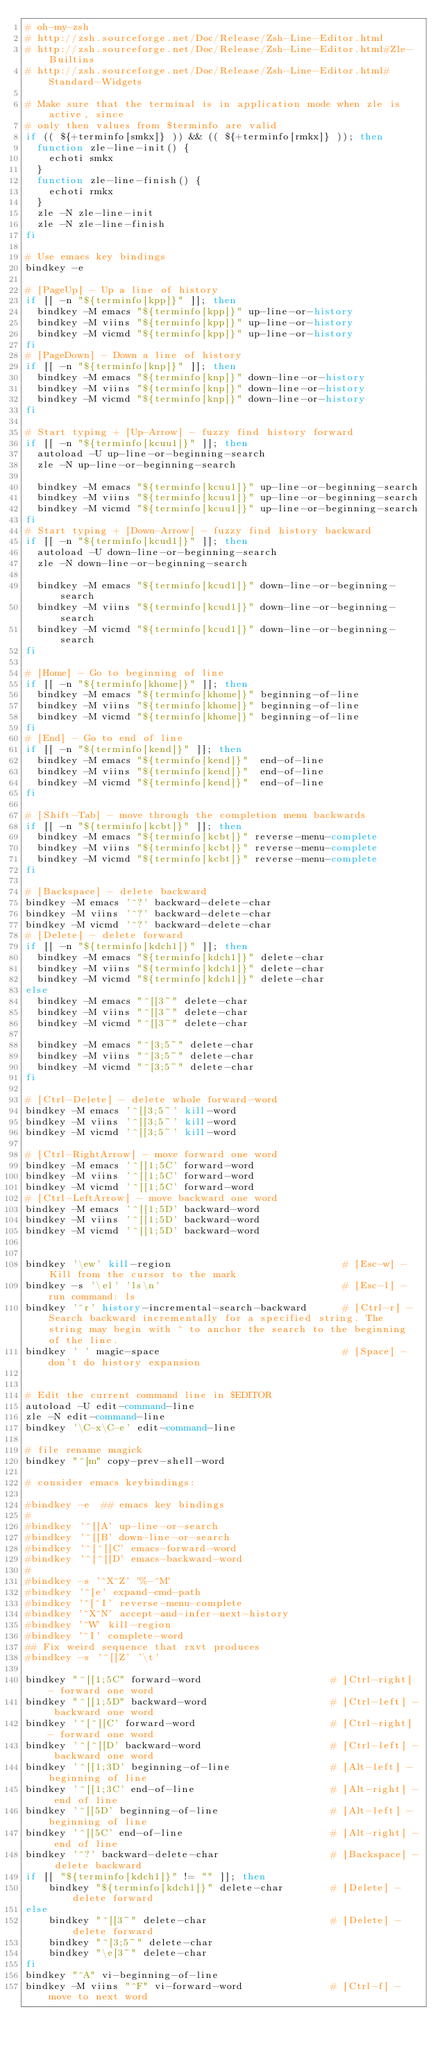Convert code to text. <code><loc_0><loc_0><loc_500><loc_500><_Bash_># oh-my-zsh
# http://zsh.sourceforge.net/Doc/Release/Zsh-Line-Editor.html
# http://zsh.sourceforge.net/Doc/Release/Zsh-Line-Editor.html#Zle-Builtins
# http://zsh.sourceforge.net/Doc/Release/Zsh-Line-Editor.html#Standard-Widgets

# Make sure that the terminal is in application mode when zle is active, since
# only then values from $terminfo are valid
if (( ${+terminfo[smkx]} )) && (( ${+terminfo[rmkx]} )); then
  function zle-line-init() {
    echoti smkx
  }
  function zle-line-finish() {
    echoti rmkx
  }
  zle -N zle-line-init
  zle -N zle-line-finish
fi

# Use emacs key bindings
bindkey -e

# [PageUp] - Up a line of history
if [[ -n "${terminfo[kpp]}" ]]; then
  bindkey -M emacs "${terminfo[kpp]}" up-line-or-history
  bindkey -M viins "${terminfo[kpp]}" up-line-or-history
  bindkey -M vicmd "${terminfo[kpp]}" up-line-or-history
fi
# [PageDown] - Down a line of history
if [[ -n "${terminfo[knp]}" ]]; then
  bindkey -M emacs "${terminfo[knp]}" down-line-or-history
  bindkey -M viins "${terminfo[knp]}" down-line-or-history
  bindkey -M vicmd "${terminfo[knp]}" down-line-or-history
fi

# Start typing + [Up-Arrow] - fuzzy find history forward
if [[ -n "${terminfo[kcuu1]}" ]]; then
  autoload -U up-line-or-beginning-search
  zle -N up-line-or-beginning-search

  bindkey -M emacs "${terminfo[kcuu1]}" up-line-or-beginning-search
  bindkey -M viins "${terminfo[kcuu1]}" up-line-or-beginning-search
  bindkey -M vicmd "${terminfo[kcuu1]}" up-line-or-beginning-search
fi
# Start typing + [Down-Arrow] - fuzzy find history backward
if [[ -n "${terminfo[kcud1]}" ]]; then
  autoload -U down-line-or-beginning-search
  zle -N down-line-or-beginning-search

  bindkey -M emacs "${terminfo[kcud1]}" down-line-or-beginning-search
  bindkey -M viins "${terminfo[kcud1]}" down-line-or-beginning-search
  bindkey -M vicmd "${terminfo[kcud1]}" down-line-or-beginning-search
fi

# [Home] - Go to beginning of line
if [[ -n "${terminfo[khome]}" ]]; then
  bindkey -M emacs "${terminfo[khome]}" beginning-of-line
  bindkey -M viins "${terminfo[khome]}" beginning-of-line
  bindkey -M vicmd "${terminfo[khome]}" beginning-of-line
fi
# [End] - Go to end of line
if [[ -n "${terminfo[kend]}" ]]; then
  bindkey -M emacs "${terminfo[kend]}"  end-of-line
  bindkey -M viins "${terminfo[kend]}"  end-of-line
  bindkey -M vicmd "${terminfo[kend]}"  end-of-line
fi

# [Shift-Tab] - move through the completion menu backwards
if [[ -n "${terminfo[kcbt]}" ]]; then
  bindkey -M emacs "${terminfo[kcbt]}" reverse-menu-complete
  bindkey -M viins "${terminfo[kcbt]}" reverse-menu-complete
  bindkey -M vicmd "${terminfo[kcbt]}" reverse-menu-complete
fi

# [Backspace] - delete backward
bindkey -M emacs '^?' backward-delete-char
bindkey -M viins '^?' backward-delete-char
bindkey -M vicmd '^?' backward-delete-char
# [Delete] - delete forward
if [[ -n "${terminfo[kdch1]}" ]]; then
  bindkey -M emacs "${terminfo[kdch1]}" delete-char
  bindkey -M viins "${terminfo[kdch1]}" delete-char
  bindkey -M vicmd "${terminfo[kdch1]}" delete-char
else
  bindkey -M emacs "^[[3~" delete-char
  bindkey -M viins "^[[3~" delete-char
  bindkey -M vicmd "^[[3~" delete-char

  bindkey -M emacs "^[3;5~" delete-char
  bindkey -M viins "^[3;5~" delete-char
  bindkey -M vicmd "^[3;5~" delete-char
fi

# [Ctrl-Delete] - delete whole forward-word
bindkey -M emacs '^[[3;5~' kill-word
bindkey -M viins '^[[3;5~' kill-word
bindkey -M vicmd '^[[3;5~' kill-word

# [Ctrl-RightArrow] - move forward one word
bindkey -M emacs '^[[1;5C' forward-word
bindkey -M viins '^[[1;5C' forward-word
bindkey -M vicmd '^[[1;5C' forward-word
# [Ctrl-LeftArrow] - move backward one word
bindkey -M emacs '^[[1;5D' backward-word
bindkey -M viins '^[[1;5D' backward-word
bindkey -M vicmd '^[[1;5D' backward-word


bindkey '\ew' kill-region                             # [Esc-w] - Kill from the cursor to the mark
bindkey -s '\el' 'ls\n'                               # [Esc-l] - run command: ls
bindkey '^r' history-incremental-search-backward      # [Ctrl-r] - Search backward incrementally for a specified string. The string may begin with ^ to anchor the search to the beginning of the line.
bindkey ' ' magic-space                               # [Space] - don't do history expansion


# Edit the current command line in $EDITOR
autoload -U edit-command-line
zle -N edit-command-line
bindkey '\C-x\C-e' edit-command-line

# file rename magick
bindkey "^[m" copy-prev-shell-word

# consider emacs keybindings:

#bindkey -e  ## emacs key bindings
#
#bindkey '^[[A' up-line-or-search
#bindkey '^[[B' down-line-or-search
#bindkey '^[^[[C' emacs-forward-word
#bindkey '^[^[[D' emacs-backward-word
#
#bindkey -s '^X^Z' '%-^M'
#bindkey '^[e' expand-cmd-path
#bindkey '^[^I' reverse-menu-complete
#bindkey '^X^N' accept-and-infer-next-history
#bindkey '^W' kill-region
#bindkey '^I' complete-word
## Fix weird sequence that rxvt produces
#bindkey -s '^[[Z' '\t'

bindkey "^[[1;5C" forward-word                      # [Ctrl-right] - forward one word
bindkey "^[[1;5D" backward-word                     # [Ctrl-left] - backward one word
bindkey '^[^[[C' forward-word                       # [Ctrl-right] - forward one word
bindkey '^[^[[D' backward-word                      # [Ctrl-left] - backward one word
bindkey '^[[1;3D' beginning-of-line                 # [Alt-left] - beginning of line
bindkey '^[[1;3C' end-of-line                       # [Alt-right] - end of line
bindkey '^[[5D' beginning-of-line                   # [Alt-left] - beginning of line
bindkey '^[[5C' end-of-line                         # [Alt-right] - end of line
bindkey '^?' backward-delete-char                   # [Backspace] - delete backward
if [[ "${terminfo[kdch1]}" != "" ]]; then
    bindkey "${terminfo[kdch1]}" delete-char        # [Delete] - delete forward
else
    bindkey "^[[3~" delete-char                     # [Delete] - delete forward
    bindkey "^[3;5~" delete-char
    bindkey "\e[3~" delete-char
fi
bindkey "^A" vi-beginning-of-line
bindkey -M viins "^F" vi-forward-word               # [Ctrl-f] - move to next word</code> 